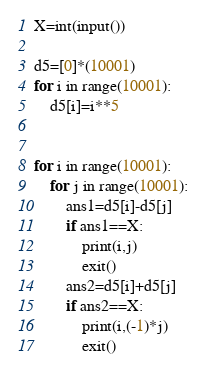Convert code to text. <code><loc_0><loc_0><loc_500><loc_500><_Python_>X=int(input())

d5=[0]*(10001)
for i in range(10001):
    d5[i]=i**5


for i in range(10001):
    for j in range(10001):
        ans1=d5[i]-d5[j]
        if ans1==X:
            print(i,j)
            exit()
        ans2=d5[i]+d5[j]
        if ans2==X:
            print(i,(-1)*j)
            exit()</code> 